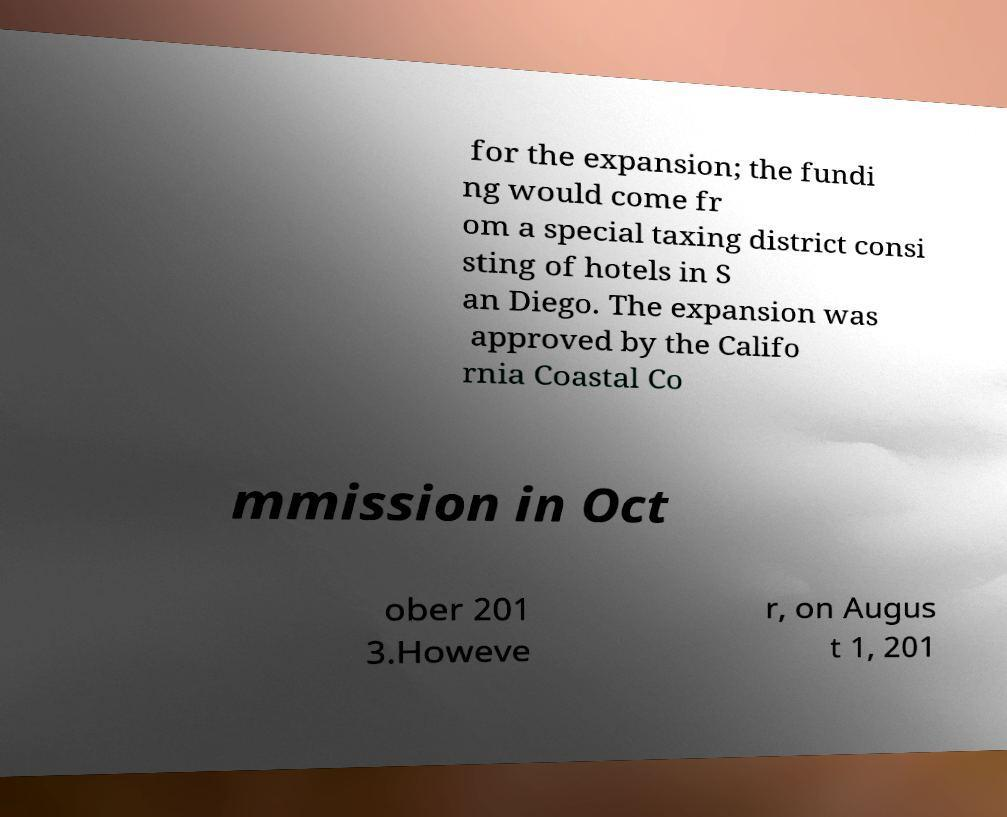Please identify and transcribe the text found in this image. for the expansion; the fundi ng would come fr om a special taxing district consi sting of hotels in S an Diego. The expansion was approved by the Califo rnia Coastal Co mmission in Oct ober 201 3.Howeve r, on Augus t 1, 201 